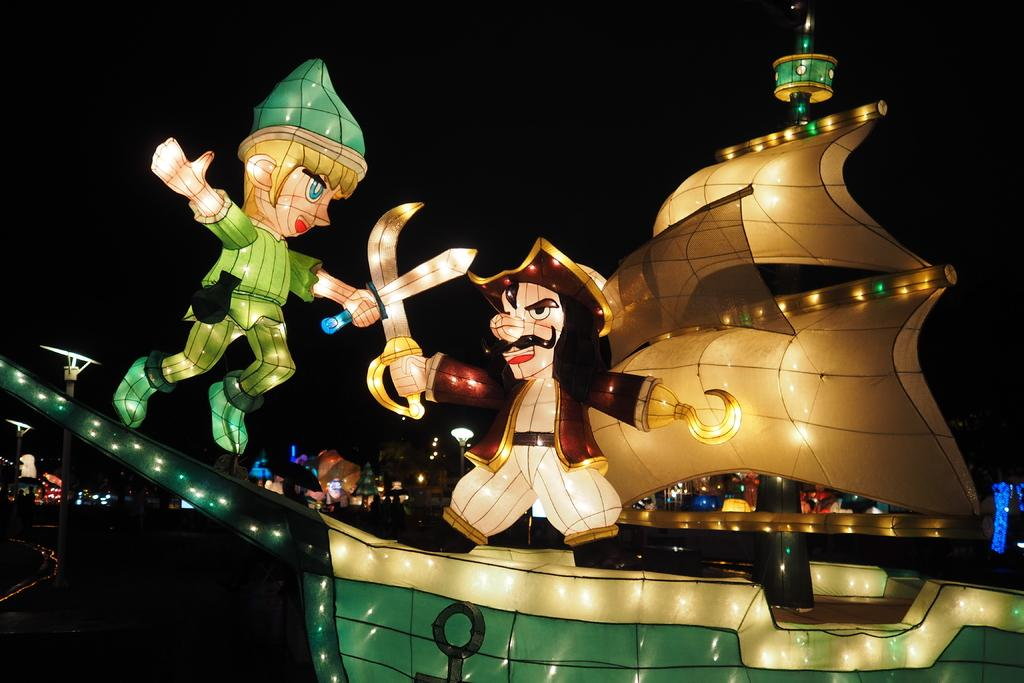What type of illustrations are present in the image? There are cartoon depictions in the image. What is the main subject of the image? There is a ship in the image. What color is the background of the image? The background of the image is black in color. How many geese are resting on the board in the image? There are no geese or boards present in the image; it features cartoon depictions of a ship with a black background. 